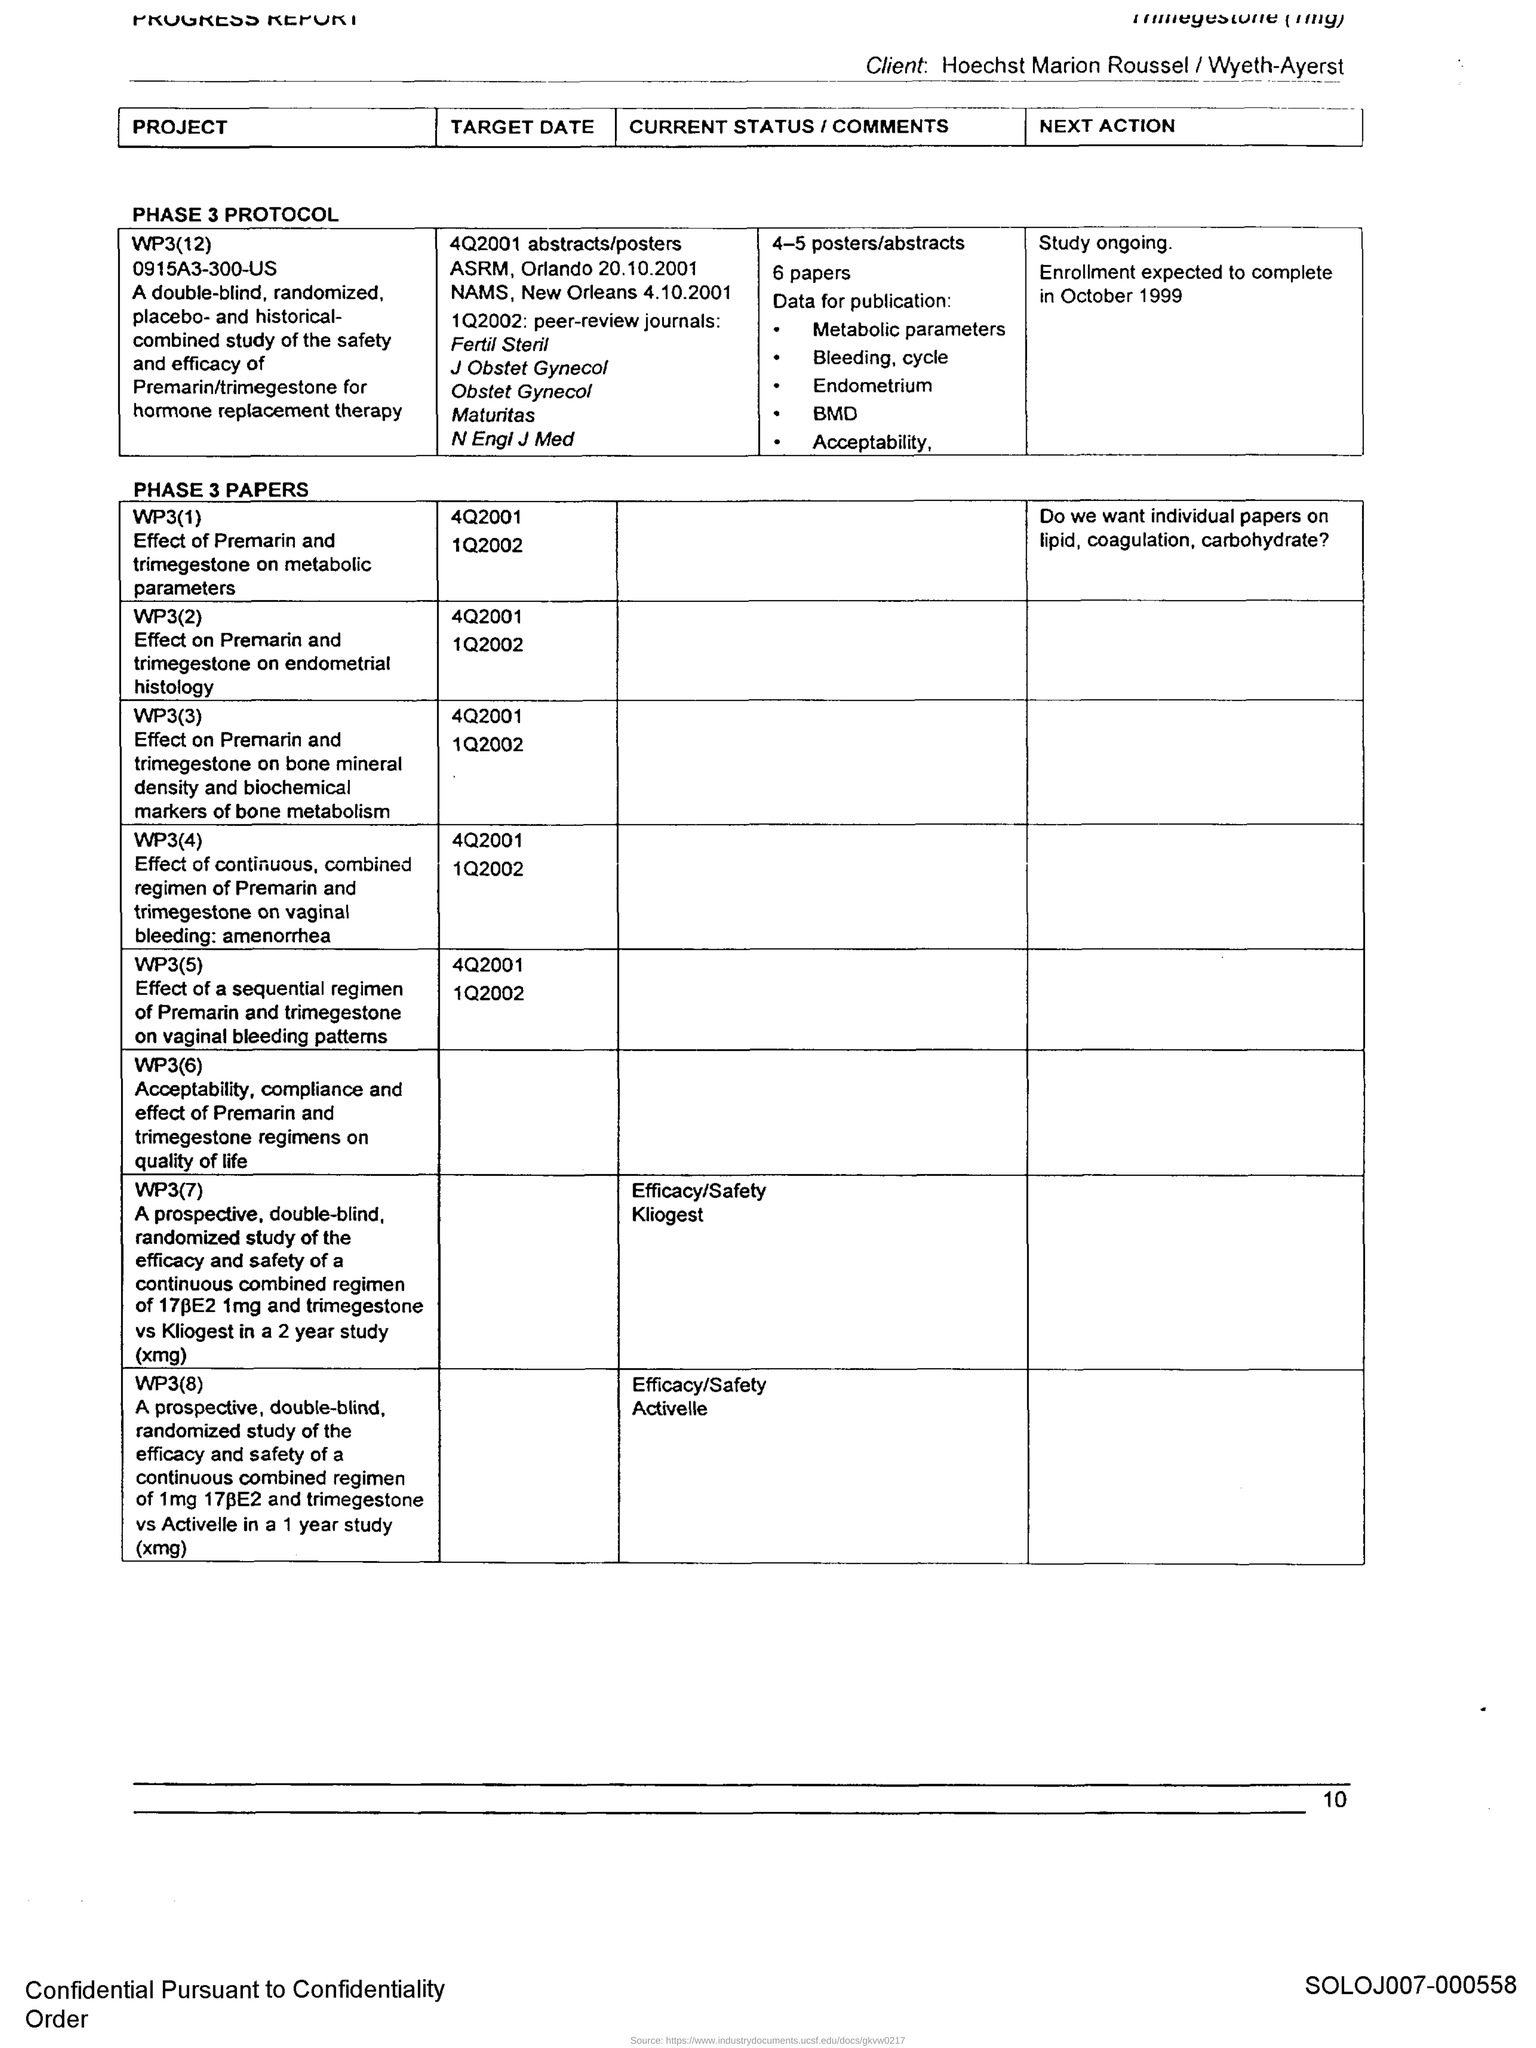Mention a couple of crucial points in this snapshot. The current status of WP3(8) is the evaluation of the efficacy and safety of the investigational drug Activelle. The page number is 10. 